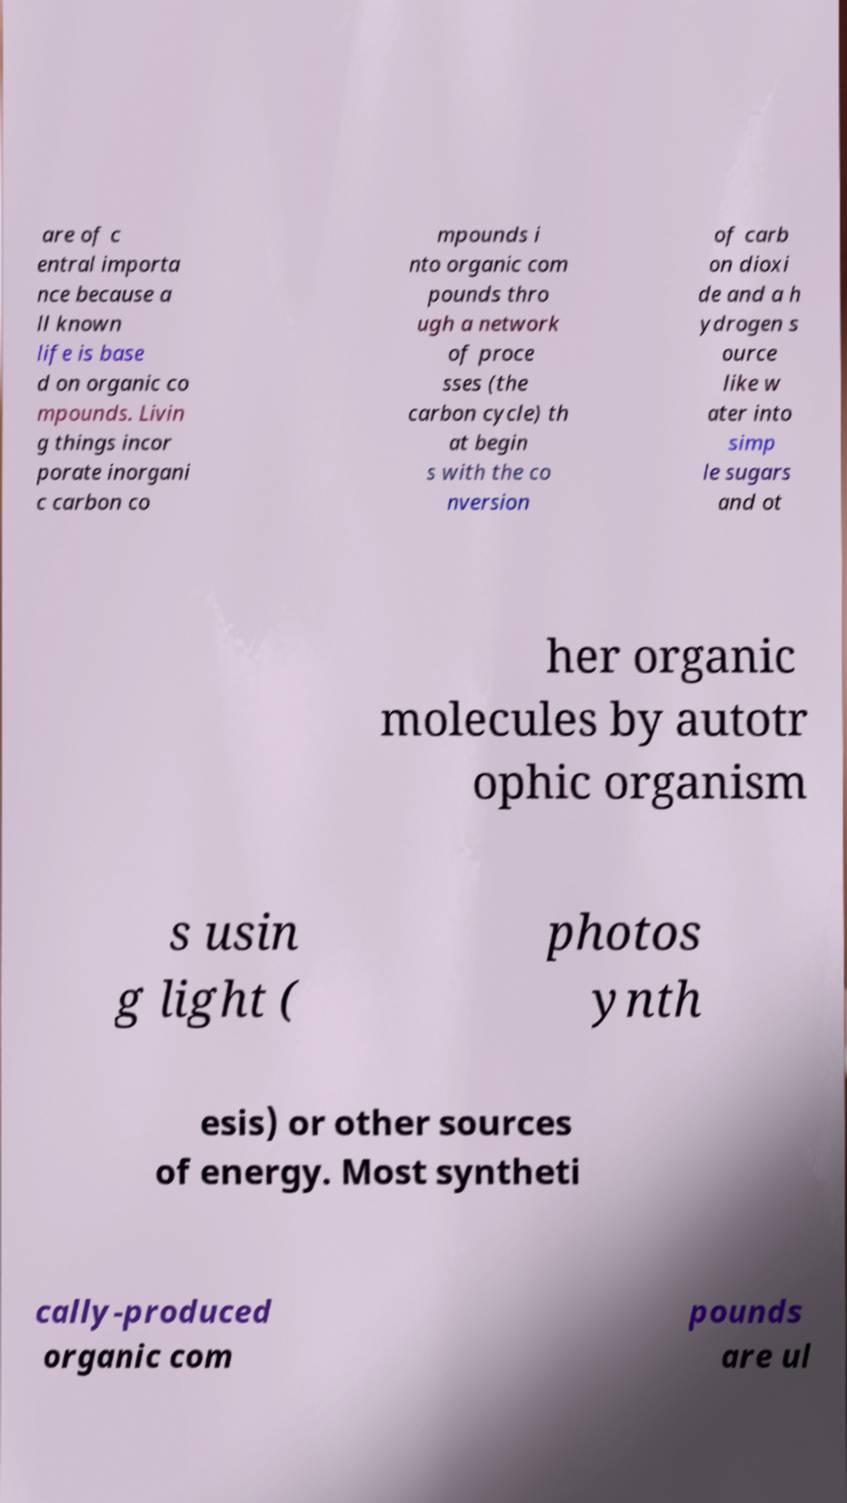What messages or text are displayed in this image? I need them in a readable, typed format. are of c entral importa nce because a ll known life is base d on organic co mpounds. Livin g things incor porate inorgani c carbon co mpounds i nto organic com pounds thro ugh a network of proce sses (the carbon cycle) th at begin s with the co nversion of carb on dioxi de and a h ydrogen s ource like w ater into simp le sugars and ot her organic molecules by autotr ophic organism s usin g light ( photos ynth esis) or other sources of energy. Most syntheti cally-produced organic com pounds are ul 